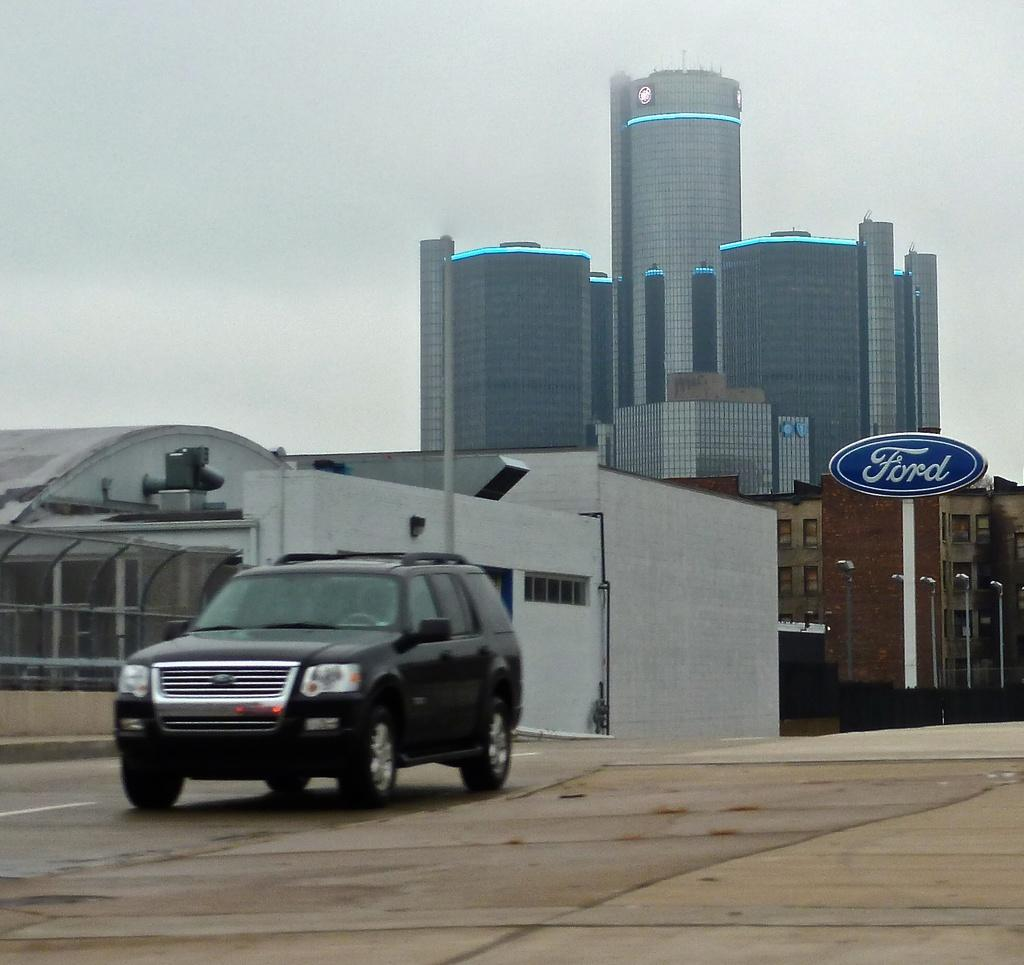What can be seen in the background of the image? The sky is visible in the image. What type of structure is in the image? There is a building in the image. What is located in front of the building? A vehicle is present in front of the building. What is on the right side of the image? There are poles on the right side of the image. What type of health advice is being given in the image? There is no indication of health advice or any health-related content in the image. 